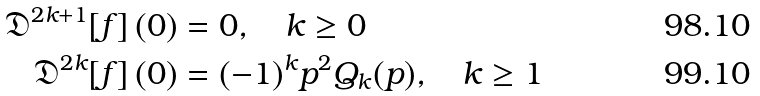Convert formula to latex. <formula><loc_0><loc_0><loc_500><loc_500>\mathfrak { D } ^ { 2 k + 1 } [ f ] \, ( 0 ) & = 0 , \quad k \geq 0 \\ \mathfrak { D } ^ { 2 k } [ f ] \, ( 0 ) & = ( - 1 ) ^ { k } p ^ { 2 } Q _ { k } ( p ) , \quad k \geq 1</formula> 